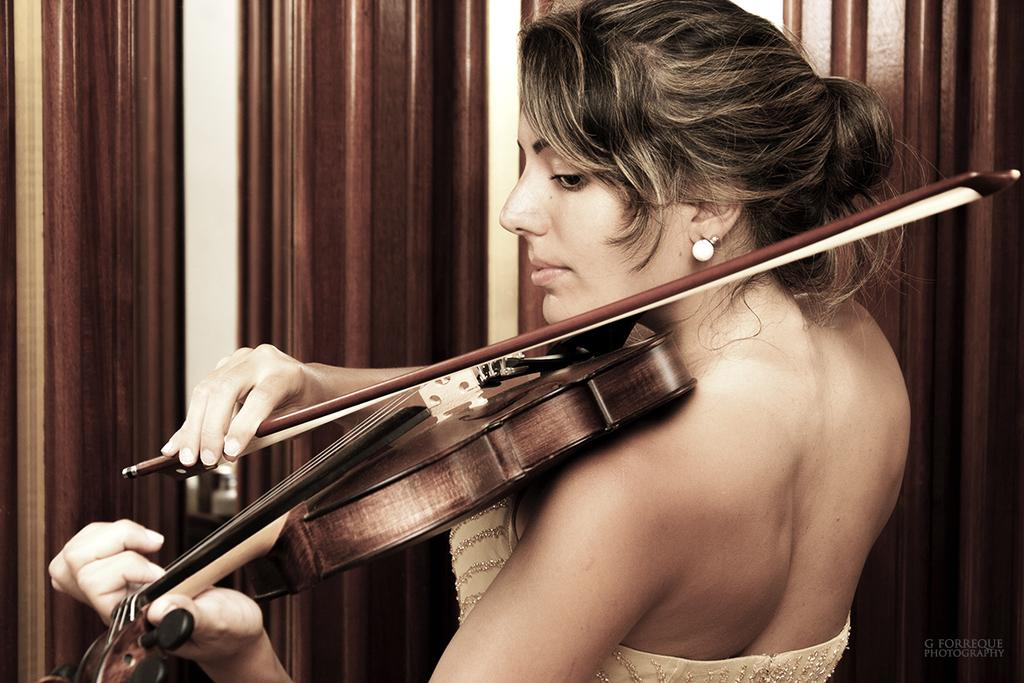What is the main subject of the image? The main subject of the image is a woman. What is the woman doing in the image? The woman is standing and playing a violin. What is the woman wearing in the image? The woman is wearing a dress and ear studs. What can be seen in the background of the image? There is a wooden texture wall in the background of the image. What type of stove can be seen in the image? There is no stove present in the image. What smell is associated with the woman's attire in the image? The image does not provide any information about the smell associated with the woman's attire. 